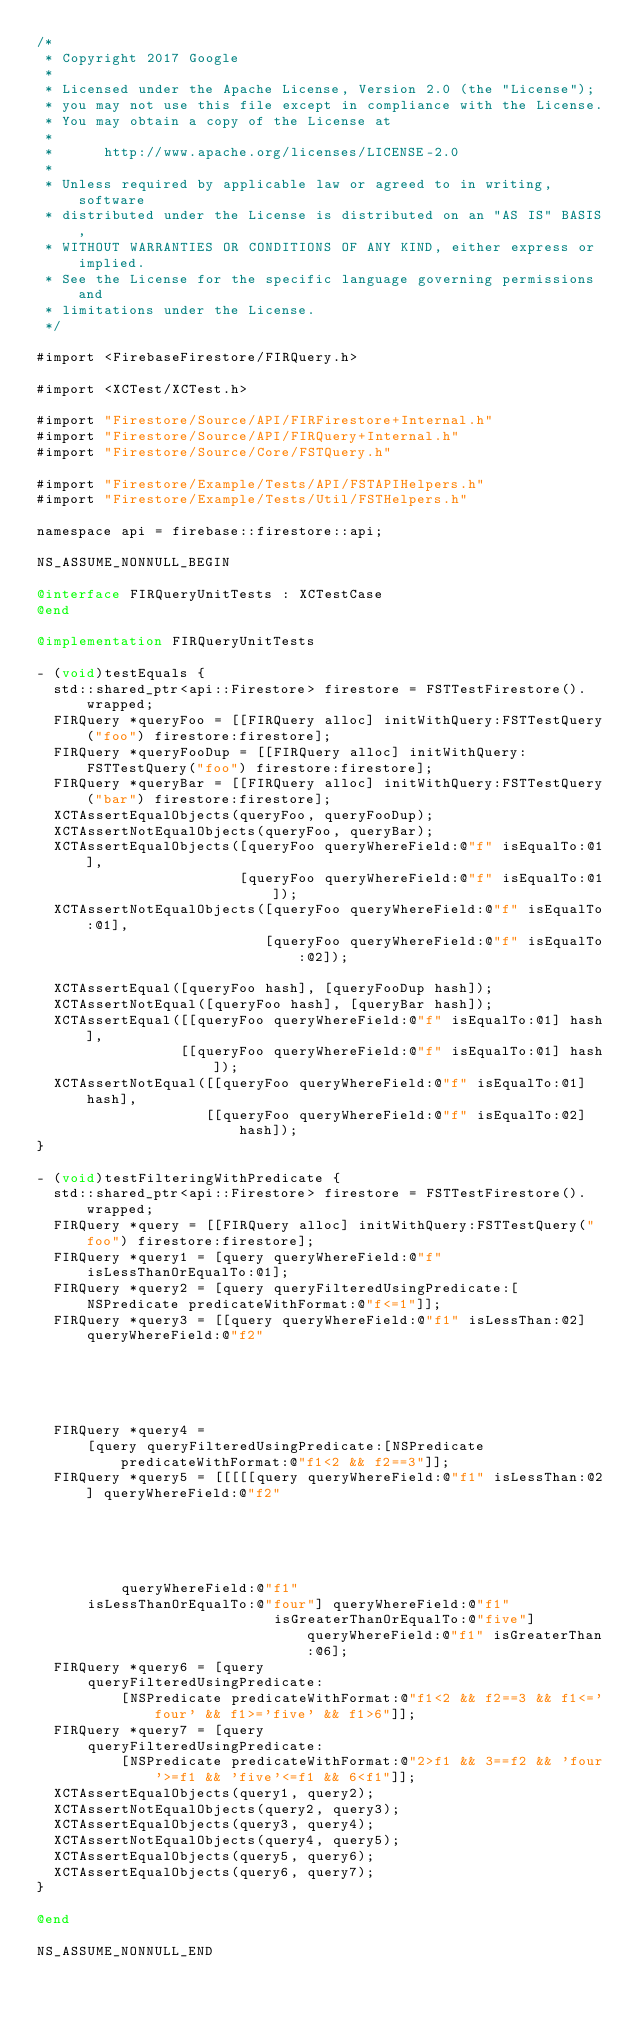Convert code to text. <code><loc_0><loc_0><loc_500><loc_500><_ObjectiveC_>/*
 * Copyright 2017 Google
 *
 * Licensed under the Apache License, Version 2.0 (the "License");
 * you may not use this file except in compliance with the License.
 * You may obtain a copy of the License at
 *
 *      http://www.apache.org/licenses/LICENSE-2.0
 *
 * Unless required by applicable law or agreed to in writing, software
 * distributed under the License is distributed on an "AS IS" BASIS,
 * WITHOUT WARRANTIES OR CONDITIONS OF ANY KIND, either express or implied.
 * See the License for the specific language governing permissions and
 * limitations under the License.
 */

#import <FirebaseFirestore/FIRQuery.h>

#import <XCTest/XCTest.h>

#import "Firestore/Source/API/FIRFirestore+Internal.h"
#import "Firestore/Source/API/FIRQuery+Internal.h"
#import "Firestore/Source/Core/FSTQuery.h"

#import "Firestore/Example/Tests/API/FSTAPIHelpers.h"
#import "Firestore/Example/Tests/Util/FSTHelpers.h"

namespace api = firebase::firestore::api;

NS_ASSUME_NONNULL_BEGIN

@interface FIRQueryUnitTests : XCTestCase
@end

@implementation FIRQueryUnitTests

- (void)testEquals {
  std::shared_ptr<api::Firestore> firestore = FSTTestFirestore().wrapped;
  FIRQuery *queryFoo = [[FIRQuery alloc] initWithQuery:FSTTestQuery("foo") firestore:firestore];
  FIRQuery *queryFooDup = [[FIRQuery alloc] initWithQuery:FSTTestQuery("foo") firestore:firestore];
  FIRQuery *queryBar = [[FIRQuery alloc] initWithQuery:FSTTestQuery("bar") firestore:firestore];
  XCTAssertEqualObjects(queryFoo, queryFooDup);
  XCTAssertNotEqualObjects(queryFoo, queryBar);
  XCTAssertEqualObjects([queryFoo queryWhereField:@"f" isEqualTo:@1],
                        [queryFoo queryWhereField:@"f" isEqualTo:@1]);
  XCTAssertNotEqualObjects([queryFoo queryWhereField:@"f" isEqualTo:@1],
                           [queryFoo queryWhereField:@"f" isEqualTo:@2]);

  XCTAssertEqual([queryFoo hash], [queryFooDup hash]);
  XCTAssertNotEqual([queryFoo hash], [queryBar hash]);
  XCTAssertEqual([[queryFoo queryWhereField:@"f" isEqualTo:@1] hash],
                 [[queryFoo queryWhereField:@"f" isEqualTo:@1] hash]);
  XCTAssertNotEqual([[queryFoo queryWhereField:@"f" isEqualTo:@1] hash],
                    [[queryFoo queryWhereField:@"f" isEqualTo:@2] hash]);
}

- (void)testFilteringWithPredicate {
  std::shared_ptr<api::Firestore> firestore = FSTTestFirestore().wrapped;
  FIRQuery *query = [[FIRQuery alloc] initWithQuery:FSTTestQuery("foo") firestore:firestore];
  FIRQuery *query1 = [query queryWhereField:@"f" isLessThanOrEqualTo:@1];
  FIRQuery *query2 = [query queryFilteredUsingPredicate:[NSPredicate predicateWithFormat:@"f<=1"]];
  FIRQuery *query3 = [[query queryWhereField:@"f1" isLessThan:@2] queryWhereField:@"f2"
                                                                        isEqualTo:@3];
  FIRQuery *query4 =
      [query queryFilteredUsingPredicate:[NSPredicate predicateWithFormat:@"f1<2 && f2==3"]];
  FIRQuery *query5 = [[[[[query queryWhereField:@"f1" isLessThan:@2] queryWhereField:@"f2"
                                                                           isEqualTo:@3]
          queryWhereField:@"f1"
      isLessThanOrEqualTo:@"four"] queryWhereField:@"f1"
                            isGreaterThanOrEqualTo:@"five"] queryWhereField:@"f1" isGreaterThan:@6];
  FIRQuery *query6 = [query
      queryFilteredUsingPredicate:
          [NSPredicate predicateWithFormat:@"f1<2 && f2==3 && f1<='four' && f1>='five' && f1>6"]];
  FIRQuery *query7 = [query
      queryFilteredUsingPredicate:
          [NSPredicate predicateWithFormat:@"2>f1 && 3==f2 && 'four'>=f1 && 'five'<=f1 && 6<f1"]];
  XCTAssertEqualObjects(query1, query2);
  XCTAssertNotEqualObjects(query2, query3);
  XCTAssertEqualObjects(query3, query4);
  XCTAssertNotEqualObjects(query4, query5);
  XCTAssertEqualObjects(query5, query6);
  XCTAssertEqualObjects(query6, query7);
}

@end

NS_ASSUME_NONNULL_END
</code> 